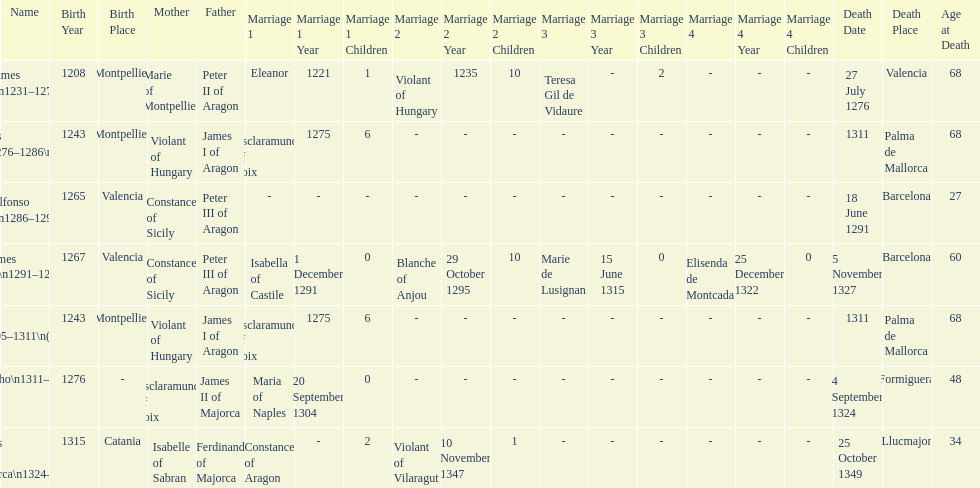How long was james ii in power, including his second rule? 26 years. 